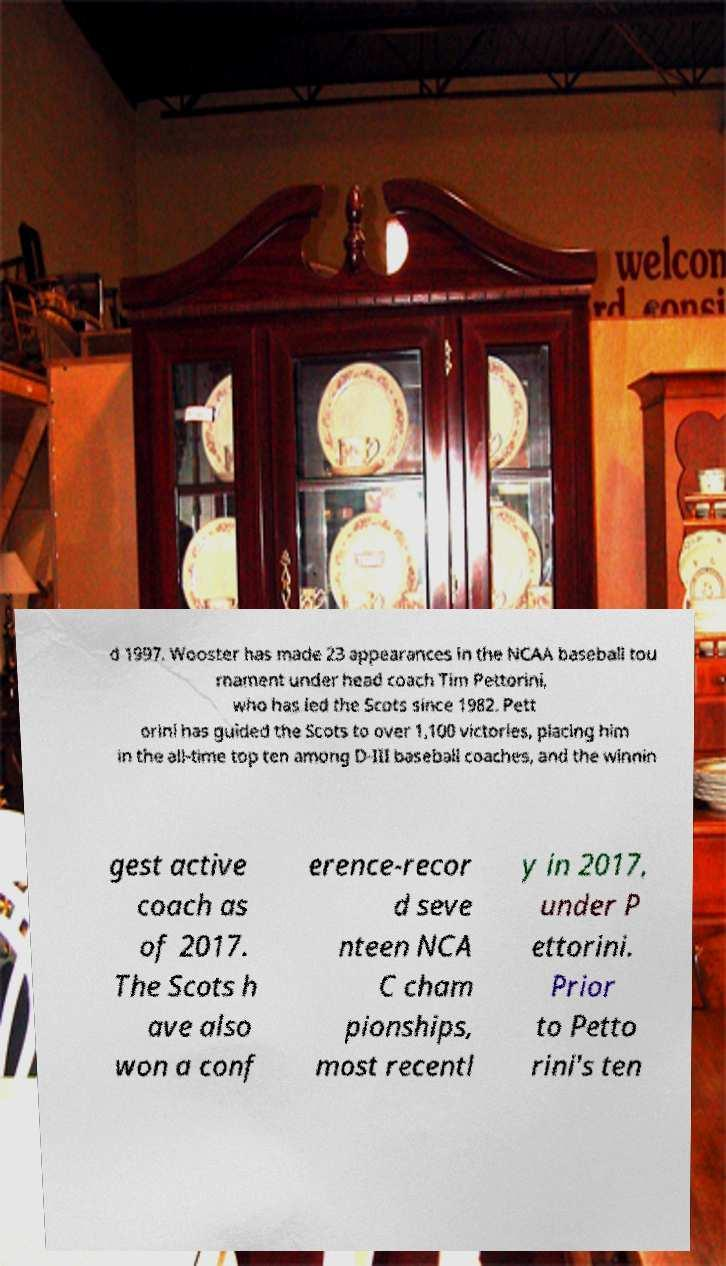There's text embedded in this image that I need extracted. Can you transcribe it verbatim? d 1997. Wooster has made 23 appearances in the NCAA baseball tou rnament under head coach Tim Pettorini, who has led the Scots since 1982. Pett orini has guided the Scots to over 1,100 victories, placing him in the all-time top ten among D-III baseball coaches, and the winnin gest active coach as of 2017. The Scots h ave also won a conf erence-recor d seve nteen NCA C cham pionships, most recentl y in 2017, under P ettorini. Prior to Petto rini's ten 